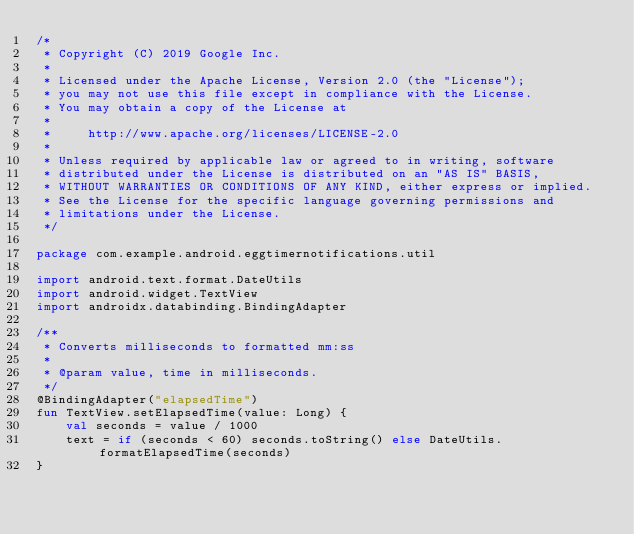Convert code to text. <code><loc_0><loc_0><loc_500><loc_500><_Kotlin_>/*
 * Copyright (C) 2019 Google Inc.
 *
 * Licensed under the Apache License, Version 2.0 (the "License");
 * you may not use this file except in compliance with the License.
 * You may obtain a copy of the License at
 *
 *     http://www.apache.org/licenses/LICENSE-2.0
 *
 * Unless required by applicable law or agreed to in writing, software
 * distributed under the License is distributed on an "AS IS" BASIS,
 * WITHOUT WARRANTIES OR CONDITIONS OF ANY KIND, either express or implied.
 * See the License for the specific language governing permissions and
 * limitations under the License.
 */

package com.example.android.eggtimernotifications.util

import android.text.format.DateUtils
import android.widget.TextView
import androidx.databinding.BindingAdapter

/**
 * Converts milliseconds to formatted mm:ss
 *
 * @param value, time in milliseconds.
 */
@BindingAdapter("elapsedTime")
fun TextView.setElapsedTime(value: Long) {
    val seconds = value / 1000
    text = if (seconds < 60) seconds.toString() else DateUtils.formatElapsedTime(seconds)
}
</code> 